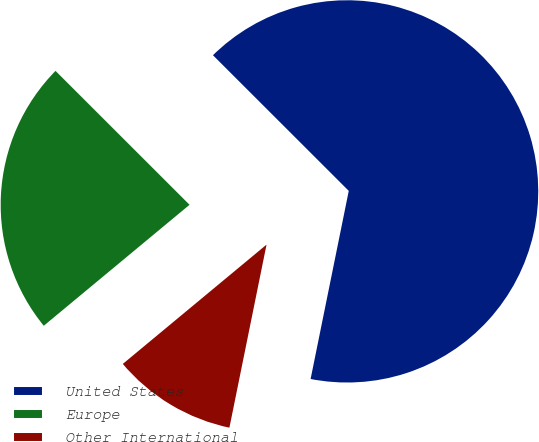<chart> <loc_0><loc_0><loc_500><loc_500><pie_chart><fcel>United States<fcel>Europe<fcel>Other International<nl><fcel>65.7%<fcel>23.52%<fcel>10.79%<nl></chart> 